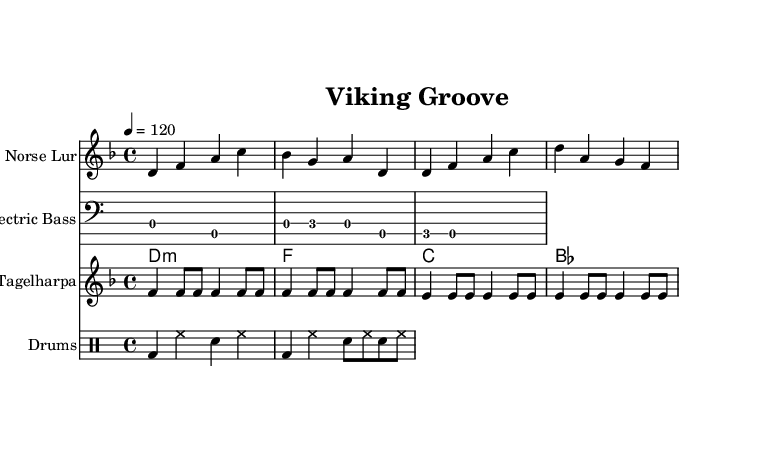What is the key signature of this music? The key signature is D minor, which is indicated by one flat (B flat) at the beginning of the staff. This indicates that the music is predominantly based around the note D and incorporates notes from the D minor scale.
Answer: D minor What is the time signature of this music? The time signature is 4/4, which is indicated by the time signature notation at the beginning of the score. This means that there are four beats in each measure and the quarter note gets one beat.
Answer: 4/4 What is the tempo marking for this piece? The tempo marking is indicated as "4 = 120," meaning there are 120 beats per minute, and that the quarter note is the basic unit of time.
Answer: 120 How many measures are in the Norse Lur part? The Norse Lur part consists of four measures as indicated by the grouping of notes and the presence of bar lines separating the measures.
Answer: 4 Which traditional instrument is featured in this score? The Tagelharpa is the traditional instrument featured in this score, as seen by its specific notation and instrument name above the staff.
Answer: Tagelharpa What style of music does this piece incorporate? The piece incorporates funk, evidenced by the rhythmic patterns and the overall groove which aligns with the characteristics of funk music.
Answer: Funk How many notes are in the first measure of the electric bass part? The first measure of the electric bass part contains three notes: D and A are played as half and quarter notes, which total three distinct note events.
Answer: 3 